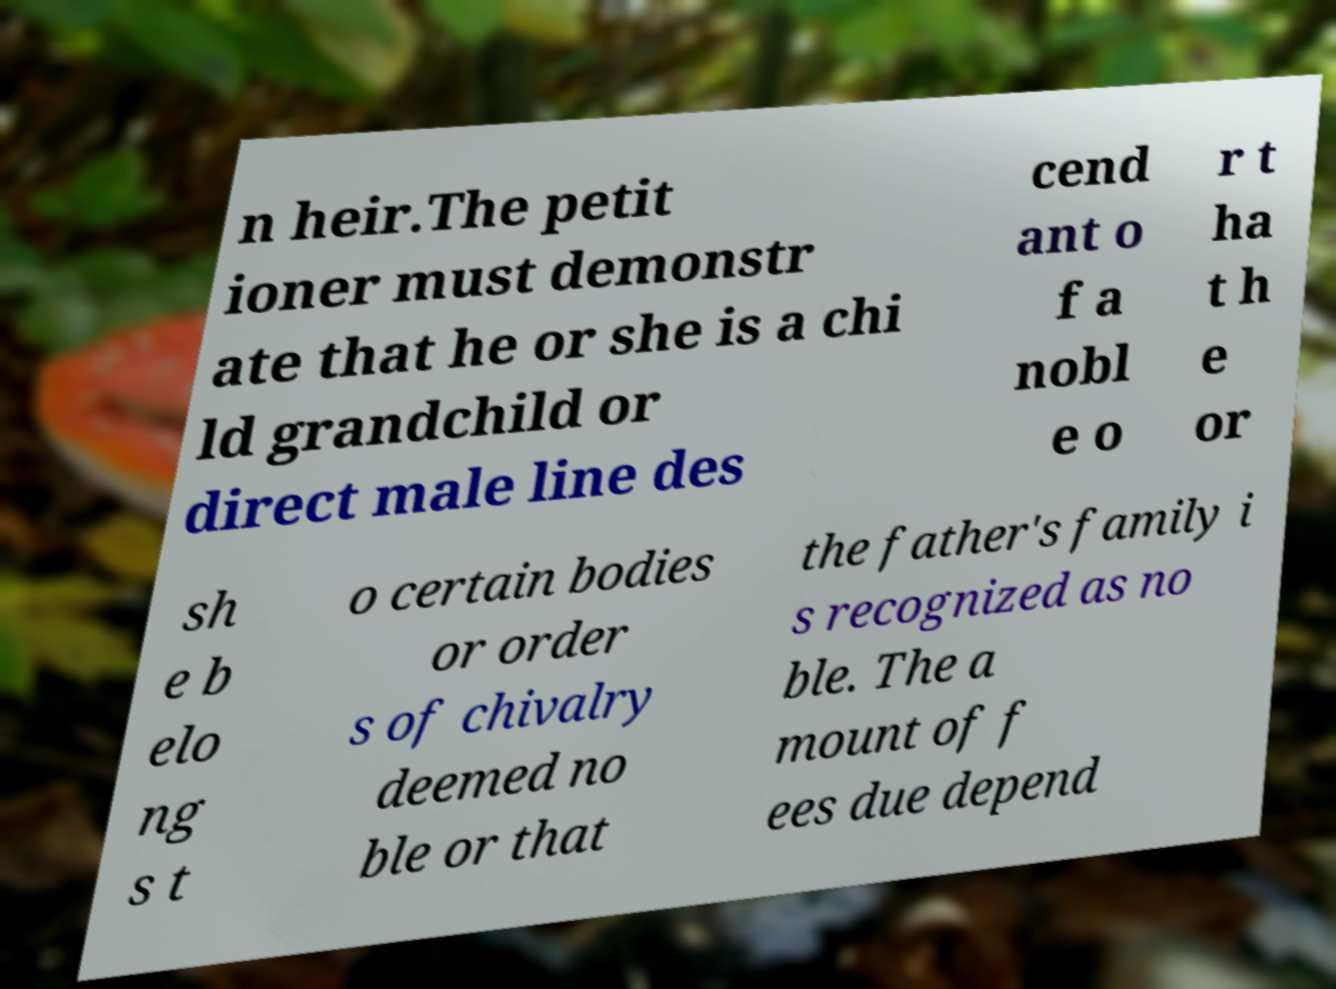For documentation purposes, I need the text within this image transcribed. Could you provide that? n heir.The petit ioner must demonstr ate that he or she is a chi ld grandchild or direct male line des cend ant o f a nobl e o r t ha t h e or sh e b elo ng s t o certain bodies or order s of chivalry deemed no ble or that the father's family i s recognized as no ble. The a mount of f ees due depend 